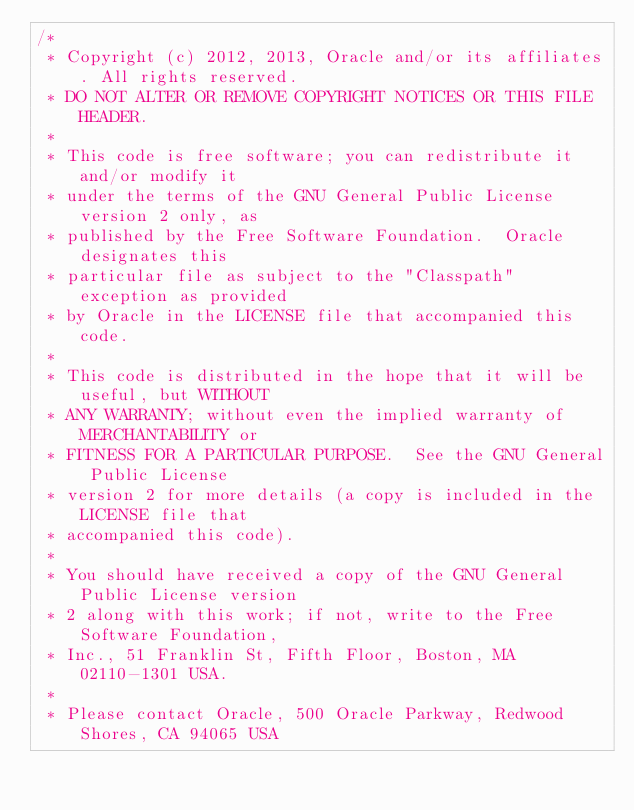<code> <loc_0><loc_0><loc_500><loc_500><_Java_>/*
 * Copyright (c) 2012, 2013, Oracle and/or its affiliates. All rights reserved.
 * DO NOT ALTER OR REMOVE COPYRIGHT NOTICES OR THIS FILE HEADER.
 *
 * This code is free software; you can redistribute it and/or modify it
 * under the terms of the GNU General Public License version 2 only, as
 * published by the Free Software Foundation.  Oracle designates this
 * particular file as subject to the "Classpath" exception as provided
 * by Oracle in the LICENSE file that accompanied this code.
 *
 * This code is distributed in the hope that it will be useful, but WITHOUT
 * ANY WARRANTY; without even the implied warranty of MERCHANTABILITY or
 * FITNESS FOR A PARTICULAR PURPOSE.  See the GNU General Public License
 * version 2 for more details (a copy is included in the LICENSE file that
 * accompanied this code).
 *
 * You should have received a copy of the GNU General Public License version
 * 2 along with this work; if not, write to the Free Software Foundation,
 * Inc., 51 Franklin St, Fifth Floor, Boston, MA 02110-1301 USA.
 *
 * Please contact Oracle, 500 Oracle Parkway, Redwood Shores, CA 94065 USA</code> 